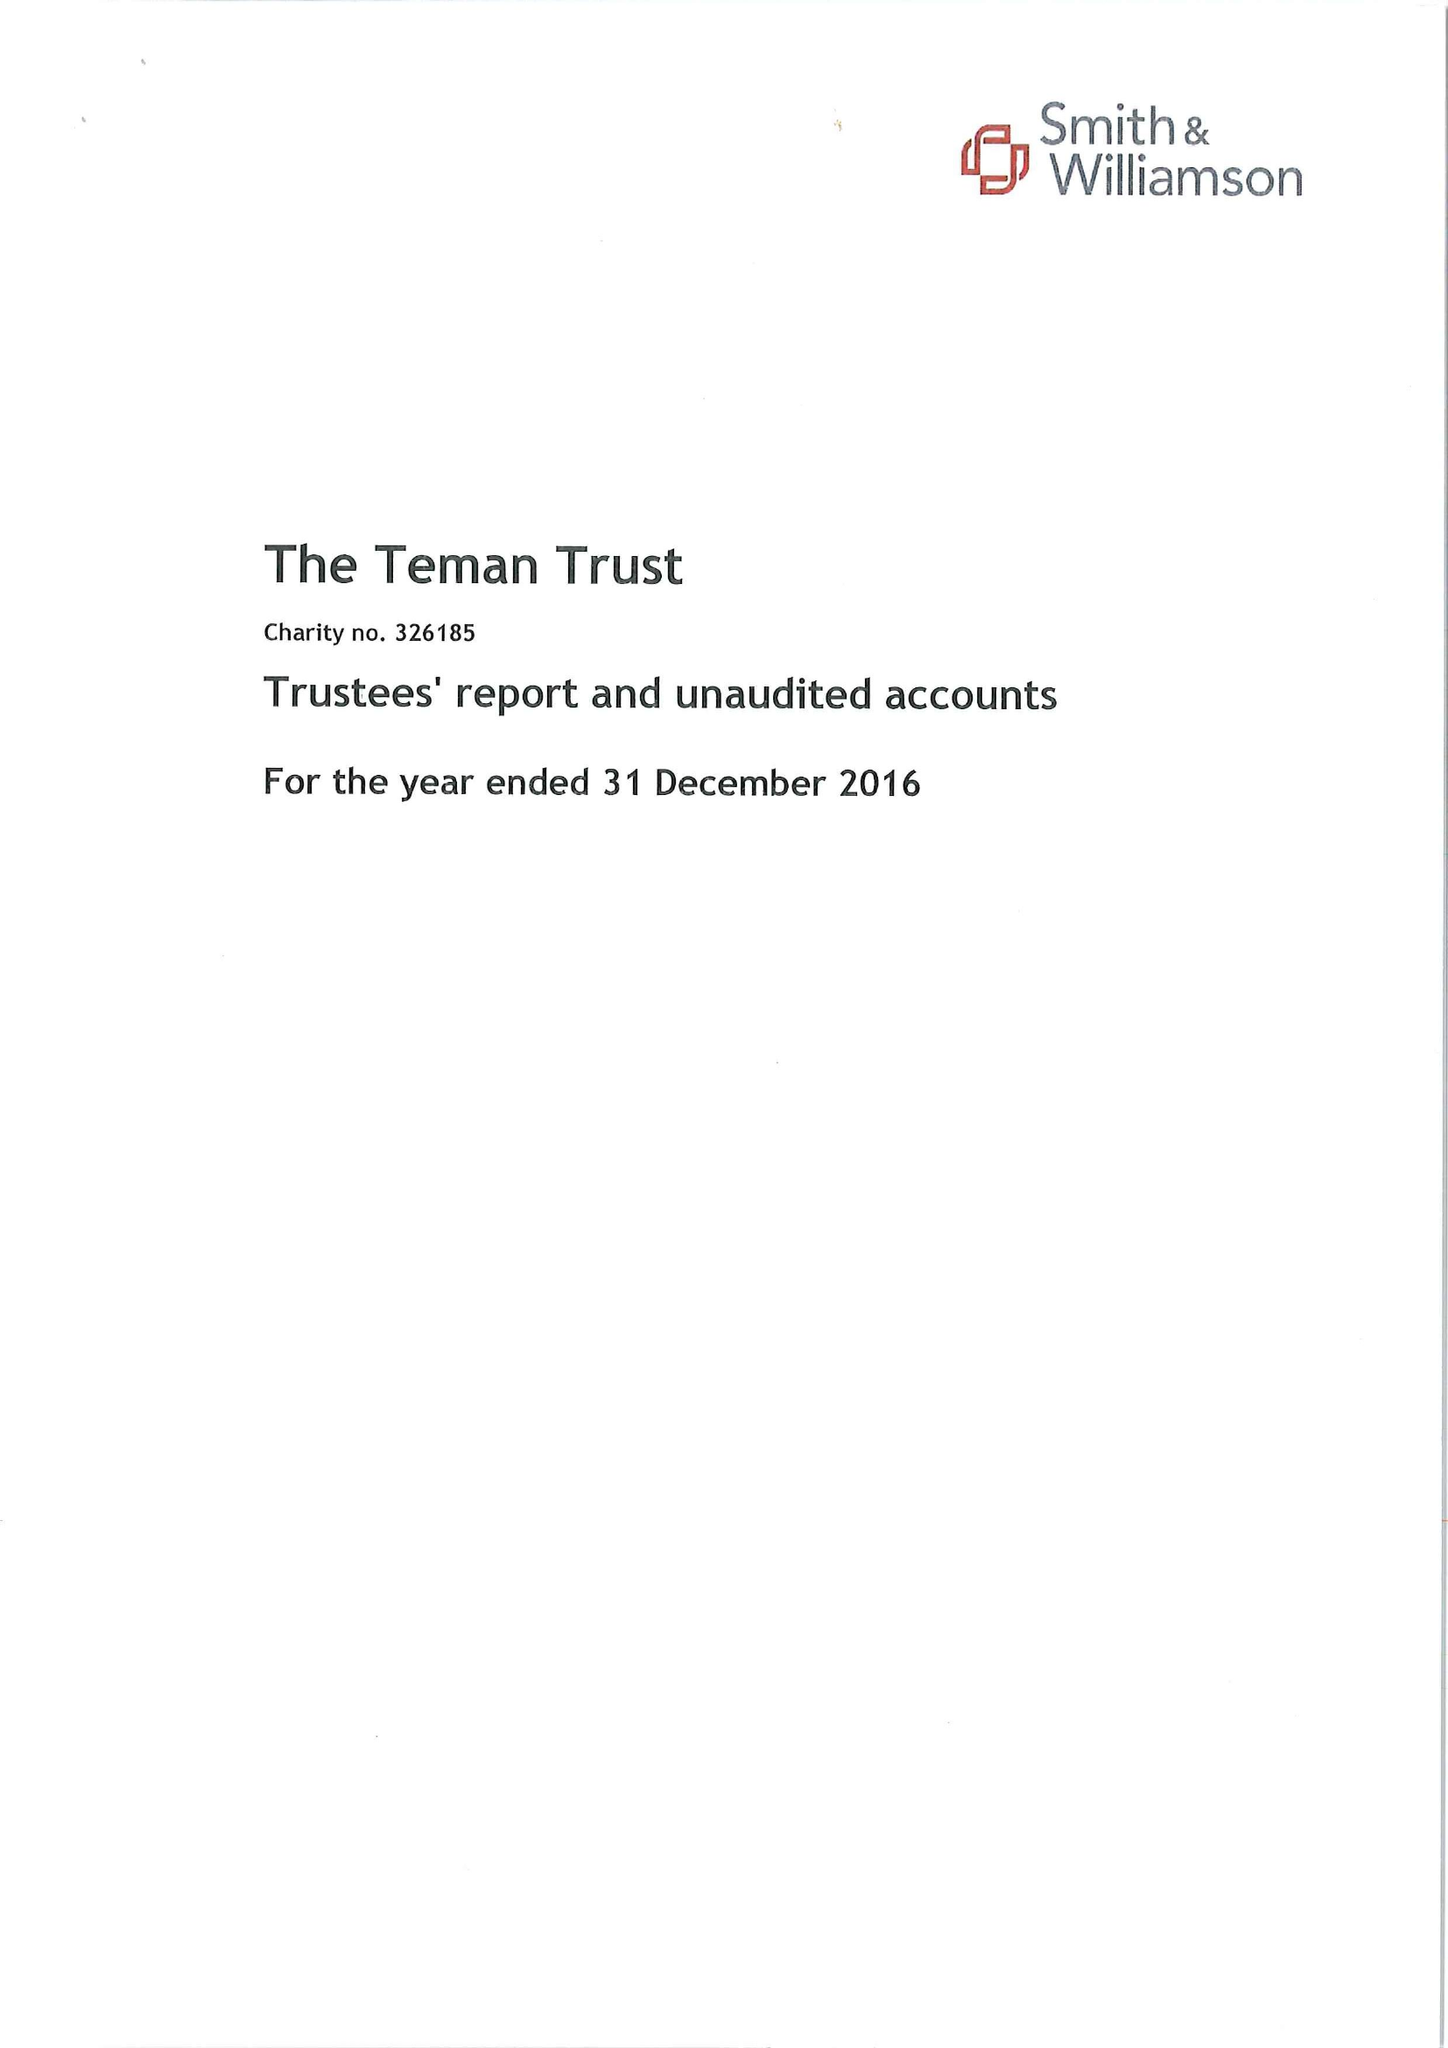What is the value for the spending_annually_in_british_pounds?
Answer the question using a single word or phrase. 37692.00 